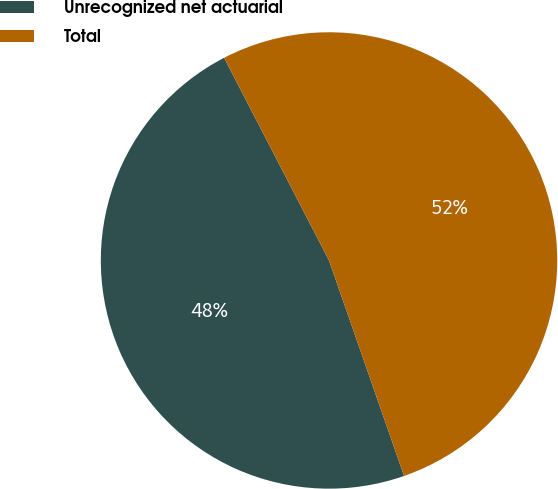Convert chart to OTSL. <chart><loc_0><loc_0><loc_500><loc_500><pie_chart><fcel>Unrecognized net actuarial<fcel>Total<nl><fcel>47.73%<fcel>52.27%<nl></chart> 